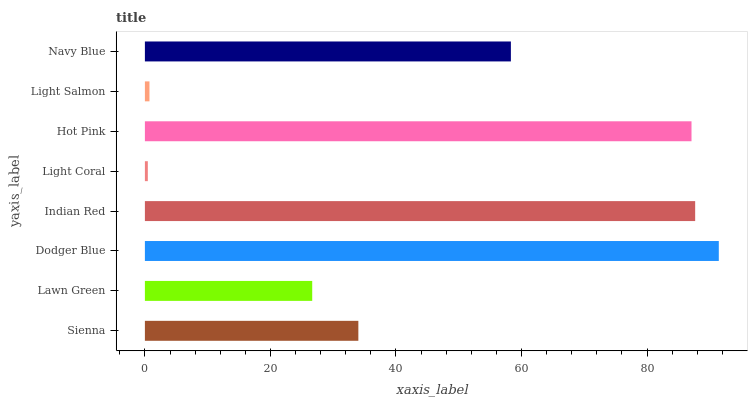Is Light Coral the minimum?
Answer yes or no. Yes. Is Dodger Blue the maximum?
Answer yes or no. Yes. Is Lawn Green the minimum?
Answer yes or no. No. Is Lawn Green the maximum?
Answer yes or no. No. Is Sienna greater than Lawn Green?
Answer yes or no. Yes. Is Lawn Green less than Sienna?
Answer yes or no. Yes. Is Lawn Green greater than Sienna?
Answer yes or no. No. Is Sienna less than Lawn Green?
Answer yes or no. No. Is Navy Blue the high median?
Answer yes or no. Yes. Is Sienna the low median?
Answer yes or no. Yes. Is Light Salmon the high median?
Answer yes or no. No. Is Light Salmon the low median?
Answer yes or no. No. 